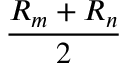<formula> <loc_0><loc_0><loc_500><loc_500>\frac { R _ { m } + R _ { n } } { 2 }</formula> 